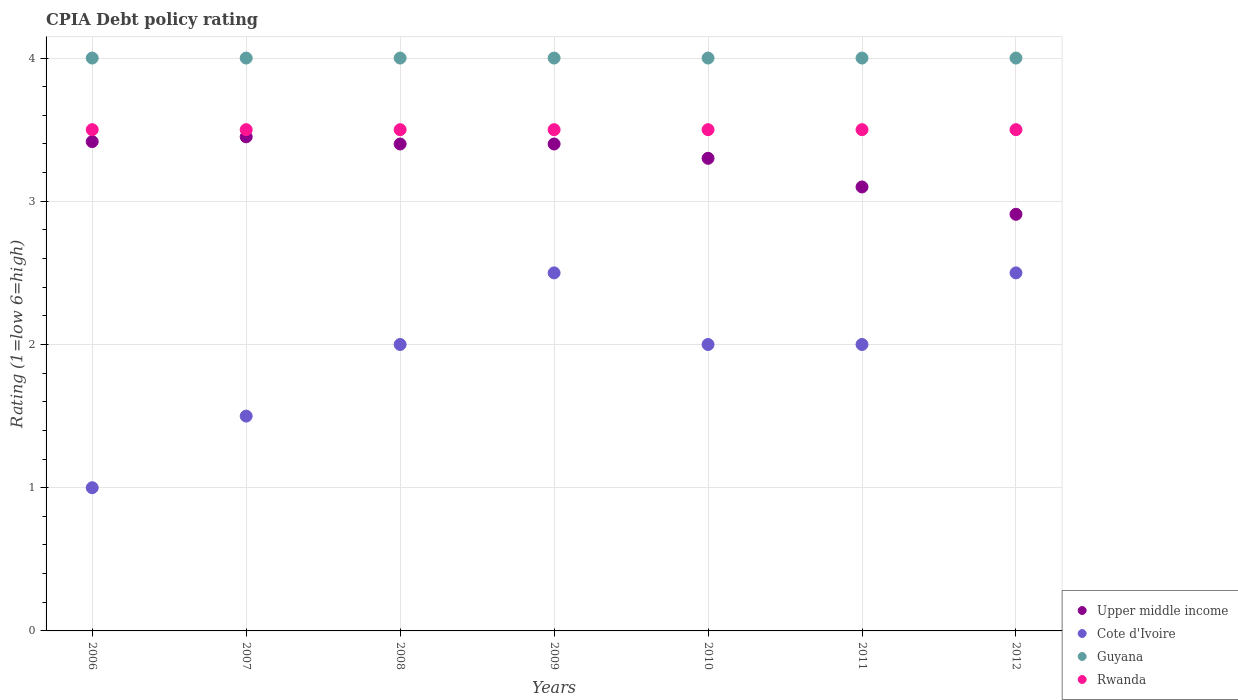What is the CPIA rating in Upper middle income in 2009?
Offer a very short reply. 3.4. In which year was the CPIA rating in Upper middle income maximum?
Ensure brevity in your answer.  2007. In which year was the CPIA rating in Upper middle income minimum?
Your response must be concise. 2012. What is the difference between the CPIA rating in Rwanda in 2006 and the CPIA rating in Cote d'Ivoire in 2008?
Your answer should be very brief. 1.5. What is the average CPIA rating in Guyana per year?
Your answer should be compact. 4. In the year 2012, what is the difference between the CPIA rating in Rwanda and CPIA rating in Upper middle income?
Keep it short and to the point. 0.59. What is the ratio of the CPIA rating in Cote d'Ivoire in 2007 to that in 2011?
Your answer should be compact. 0.75. Is the difference between the CPIA rating in Rwanda in 2008 and 2010 greater than the difference between the CPIA rating in Upper middle income in 2008 and 2010?
Your response must be concise. No. In how many years, is the CPIA rating in Upper middle income greater than the average CPIA rating in Upper middle income taken over all years?
Your answer should be very brief. 5. Is the sum of the CPIA rating in Upper middle income in 2007 and 2010 greater than the maximum CPIA rating in Guyana across all years?
Give a very brief answer. Yes. Is it the case that in every year, the sum of the CPIA rating in Rwanda and CPIA rating in Guyana  is greater than the sum of CPIA rating in Upper middle income and CPIA rating in Cote d'Ivoire?
Provide a short and direct response. Yes. Is it the case that in every year, the sum of the CPIA rating in Cote d'Ivoire and CPIA rating in Rwanda  is greater than the CPIA rating in Upper middle income?
Provide a short and direct response. Yes. Is the CPIA rating in Rwanda strictly greater than the CPIA rating in Guyana over the years?
Keep it short and to the point. No. How many years are there in the graph?
Offer a terse response. 7. Are the values on the major ticks of Y-axis written in scientific E-notation?
Your answer should be compact. No. Does the graph contain any zero values?
Give a very brief answer. No. What is the title of the graph?
Your answer should be compact. CPIA Debt policy rating. What is the label or title of the Y-axis?
Your response must be concise. Rating (1=low 6=high). What is the Rating (1=low 6=high) in Upper middle income in 2006?
Offer a terse response. 3.42. What is the Rating (1=low 6=high) of Cote d'Ivoire in 2006?
Offer a very short reply. 1. What is the Rating (1=low 6=high) in Upper middle income in 2007?
Offer a very short reply. 3.45. What is the Rating (1=low 6=high) in Rwanda in 2007?
Your answer should be compact. 3.5. What is the Rating (1=low 6=high) of Upper middle income in 2008?
Your answer should be compact. 3.4. What is the Rating (1=low 6=high) of Cote d'Ivoire in 2009?
Your answer should be very brief. 2.5. What is the Rating (1=low 6=high) of Guyana in 2010?
Ensure brevity in your answer.  4. What is the Rating (1=low 6=high) of Rwanda in 2010?
Keep it short and to the point. 3.5. What is the Rating (1=low 6=high) in Upper middle income in 2012?
Ensure brevity in your answer.  2.91. What is the Rating (1=low 6=high) in Cote d'Ivoire in 2012?
Your answer should be very brief. 2.5. Across all years, what is the maximum Rating (1=low 6=high) of Upper middle income?
Offer a very short reply. 3.45. Across all years, what is the minimum Rating (1=low 6=high) of Upper middle income?
Offer a very short reply. 2.91. Across all years, what is the minimum Rating (1=low 6=high) in Guyana?
Keep it short and to the point. 4. What is the total Rating (1=low 6=high) in Upper middle income in the graph?
Provide a short and direct response. 22.98. What is the total Rating (1=low 6=high) in Guyana in the graph?
Your response must be concise. 28. What is the difference between the Rating (1=low 6=high) of Upper middle income in 2006 and that in 2007?
Make the answer very short. -0.03. What is the difference between the Rating (1=low 6=high) in Rwanda in 2006 and that in 2007?
Provide a short and direct response. 0. What is the difference between the Rating (1=low 6=high) of Upper middle income in 2006 and that in 2008?
Provide a short and direct response. 0.02. What is the difference between the Rating (1=low 6=high) in Cote d'Ivoire in 2006 and that in 2008?
Keep it short and to the point. -1. What is the difference between the Rating (1=low 6=high) of Upper middle income in 2006 and that in 2009?
Keep it short and to the point. 0.02. What is the difference between the Rating (1=low 6=high) in Cote d'Ivoire in 2006 and that in 2009?
Give a very brief answer. -1.5. What is the difference between the Rating (1=low 6=high) in Guyana in 2006 and that in 2009?
Offer a very short reply. 0. What is the difference between the Rating (1=low 6=high) of Rwanda in 2006 and that in 2009?
Offer a terse response. 0. What is the difference between the Rating (1=low 6=high) in Upper middle income in 2006 and that in 2010?
Provide a short and direct response. 0.12. What is the difference between the Rating (1=low 6=high) in Cote d'Ivoire in 2006 and that in 2010?
Provide a short and direct response. -1. What is the difference between the Rating (1=low 6=high) in Guyana in 2006 and that in 2010?
Keep it short and to the point. 0. What is the difference between the Rating (1=low 6=high) of Rwanda in 2006 and that in 2010?
Your answer should be very brief. 0. What is the difference between the Rating (1=low 6=high) of Upper middle income in 2006 and that in 2011?
Your response must be concise. 0.32. What is the difference between the Rating (1=low 6=high) in Guyana in 2006 and that in 2011?
Provide a succinct answer. 0. What is the difference between the Rating (1=low 6=high) in Rwanda in 2006 and that in 2011?
Offer a terse response. 0. What is the difference between the Rating (1=low 6=high) of Upper middle income in 2006 and that in 2012?
Your answer should be very brief. 0.51. What is the difference between the Rating (1=low 6=high) in Cote d'Ivoire in 2006 and that in 2012?
Your answer should be very brief. -1.5. What is the difference between the Rating (1=low 6=high) of Rwanda in 2006 and that in 2012?
Provide a short and direct response. 0. What is the difference between the Rating (1=low 6=high) in Cote d'Ivoire in 2007 and that in 2008?
Keep it short and to the point. -0.5. What is the difference between the Rating (1=low 6=high) of Upper middle income in 2007 and that in 2009?
Offer a very short reply. 0.05. What is the difference between the Rating (1=low 6=high) of Cote d'Ivoire in 2007 and that in 2009?
Your answer should be compact. -1. What is the difference between the Rating (1=low 6=high) of Rwanda in 2007 and that in 2009?
Provide a succinct answer. 0. What is the difference between the Rating (1=low 6=high) in Upper middle income in 2007 and that in 2010?
Your answer should be very brief. 0.15. What is the difference between the Rating (1=low 6=high) of Rwanda in 2007 and that in 2010?
Your answer should be compact. 0. What is the difference between the Rating (1=low 6=high) in Upper middle income in 2007 and that in 2011?
Provide a short and direct response. 0.35. What is the difference between the Rating (1=low 6=high) of Cote d'Ivoire in 2007 and that in 2011?
Ensure brevity in your answer.  -0.5. What is the difference between the Rating (1=low 6=high) of Upper middle income in 2007 and that in 2012?
Provide a short and direct response. 0.54. What is the difference between the Rating (1=low 6=high) in Guyana in 2007 and that in 2012?
Make the answer very short. 0. What is the difference between the Rating (1=low 6=high) in Upper middle income in 2008 and that in 2009?
Make the answer very short. 0. What is the difference between the Rating (1=low 6=high) of Cote d'Ivoire in 2008 and that in 2010?
Your response must be concise. 0. What is the difference between the Rating (1=low 6=high) of Guyana in 2008 and that in 2010?
Give a very brief answer. 0. What is the difference between the Rating (1=low 6=high) in Upper middle income in 2008 and that in 2011?
Make the answer very short. 0.3. What is the difference between the Rating (1=low 6=high) of Guyana in 2008 and that in 2011?
Your answer should be compact. 0. What is the difference between the Rating (1=low 6=high) of Upper middle income in 2008 and that in 2012?
Your answer should be compact. 0.49. What is the difference between the Rating (1=low 6=high) in Guyana in 2008 and that in 2012?
Provide a short and direct response. 0. What is the difference between the Rating (1=low 6=high) of Upper middle income in 2009 and that in 2010?
Provide a short and direct response. 0.1. What is the difference between the Rating (1=low 6=high) in Rwanda in 2009 and that in 2010?
Give a very brief answer. 0. What is the difference between the Rating (1=low 6=high) in Cote d'Ivoire in 2009 and that in 2011?
Provide a succinct answer. 0.5. What is the difference between the Rating (1=low 6=high) of Guyana in 2009 and that in 2011?
Provide a short and direct response. 0. What is the difference between the Rating (1=low 6=high) in Upper middle income in 2009 and that in 2012?
Ensure brevity in your answer.  0.49. What is the difference between the Rating (1=low 6=high) of Cote d'Ivoire in 2009 and that in 2012?
Make the answer very short. 0. What is the difference between the Rating (1=low 6=high) in Rwanda in 2009 and that in 2012?
Offer a terse response. 0. What is the difference between the Rating (1=low 6=high) of Upper middle income in 2010 and that in 2011?
Provide a short and direct response. 0.2. What is the difference between the Rating (1=low 6=high) in Cote d'Ivoire in 2010 and that in 2011?
Your answer should be very brief. 0. What is the difference between the Rating (1=low 6=high) of Guyana in 2010 and that in 2011?
Your answer should be compact. 0. What is the difference between the Rating (1=low 6=high) in Rwanda in 2010 and that in 2011?
Provide a short and direct response. 0. What is the difference between the Rating (1=low 6=high) of Upper middle income in 2010 and that in 2012?
Your answer should be very brief. 0.39. What is the difference between the Rating (1=low 6=high) in Guyana in 2010 and that in 2012?
Your response must be concise. 0. What is the difference between the Rating (1=low 6=high) of Upper middle income in 2011 and that in 2012?
Ensure brevity in your answer.  0.19. What is the difference between the Rating (1=low 6=high) in Upper middle income in 2006 and the Rating (1=low 6=high) in Cote d'Ivoire in 2007?
Provide a short and direct response. 1.92. What is the difference between the Rating (1=low 6=high) in Upper middle income in 2006 and the Rating (1=low 6=high) in Guyana in 2007?
Provide a short and direct response. -0.58. What is the difference between the Rating (1=low 6=high) of Upper middle income in 2006 and the Rating (1=low 6=high) of Rwanda in 2007?
Provide a short and direct response. -0.08. What is the difference between the Rating (1=low 6=high) in Cote d'Ivoire in 2006 and the Rating (1=low 6=high) in Guyana in 2007?
Your response must be concise. -3. What is the difference between the Rating (1=low 6=high) in Cote d'Ivoire in 2006 and the Rating (1=low 6=high) in Rwanda in 2007?
Provide a short and direct response. -2.5. What is the difference between the Rating (1=low 6=high) of Guyana in 2006 and the Rating (1=low 6=high) of Rwanda in 2007?
Your response must be concise. 0.5. What is the difference between the Rating (1=low 6=high) in Upper middle income in 2006 and the Rating (1=low 6=high) in Cote d'Ivoire in 2008?
Give a very brief answer. 1.42. What is the difference between the Rating (1=low 6=high) of Upper middle income in 2006 and the Rating (1=low 6=high) of Guyana in 2008?
Ensure brevity in your answer.  -0.58. What is the difference between the Rating (1=low 6=high) in Upper middle income in 2006 and the Rating (1=low 6=high) in Rwanda in 2008?
Your answer should be compact. -0.08. What is the difference between the Rating (1=low 6=high) in Cote d'Ivoire in 2006 and the Rating (1=low 6=high) in Guyana in 2008?
Give a very brief answer. -3. What is the difference between the Rating (1=low 6=high) of Cote d'Ivoire in 2006 and the Rating (1=low 6=high) of Rwanda in 2008?
Offer a very short reply. -2.5. What is the difference between the Rating (1=low 6=high) of Upper middle income in 2006 and the Rating (1=low 6=high) of Guyana in 2009?
Your answer should be compact. -0.58. What is the difference between the Rating (1=low 6=high) in Upper middle income in 2006 and the Rating (1=low 6=high) in Rwanda in 2009?
Offer a very short reply. -0.08. What is the difference between the Rating (1=low 6=high) in Cote d'Ivoire in 2006 and the Rating (1=low 6=high) in Guyana in 2009?
Your answer should be compact. -3. What is the difference between the Rating (1=low 6=high) in Guyana in 2006 and the Rating (1=low 6=high) in Rwanda in 2009?
Offer a very short reply. 0.5. What is the difference between the Rating (1=low 6=high) of Upper middle income in 2006 and the Rating (1=low 6=high) of Cote d'Ivoire in 2010?
Give a very brief answer. 1.42. What is the difference between the Rating (1=low 6=high) in Upper middle income in 2006 and the Rating (1=low 6=high) in Guyana in 2010?
Provide a short and direct response. -0.58. What is the difference between the Rating (1=low 6=high) in Upper middle income in 2006 and the Rating (1=low 6=high) in Rwanda in 2010?
Give a very brief answer. -0.08. What is the difference between the Rating (1=low 6=high) in Cote d'Ivoire in 2006 and the Rating (1=low 6=high) in Guyana in 2010?
Provide a short and direct response. -3. What is the difference between the Rating (1=low 6=high) of Upper middle income in 2006 and the Rating (1=low 6=high) of Cote d'Ivoire in 2011?
Your answer should be very brief. 1.42. What is the difference between the Rating (1=low 6=high) of Upper middle income in 2006 and the Rating (1=low 6=high) of Guyana in 2011?
Your answer should be very brief. -0.58. What is the difference between the Rating (1=low 6=high) of Upper middle income in 2006 and the Rating (1=low 6=high) of Rwanda in 2011?
Provide a succinct answer. -0.08. What is the difference between the Rating (1=low 6=high) of Cote d'Ivoire in 2006 and the Rating (1=low 6=high) of Guyana in 2011?
Give a very brief answer. -3. What is the difference between the Rating (1=low 6=high) of Upper middle income in 2006 and the Rating (1=low 6=high) of Cote d'Ivoire in 2012?
Give a very brief answer. 0.92. What is the difference between the Rating (1=low 6=high) in Upper middle income in 2006 and the Rating (1=low 6=high) in Guyana in 2012?
Your answer should be very brief. -0.58. What is the difference between the Rating (1=low 6=high) in Upper middle income in 2006 and the Rating (1=low 6=high) in Rwanda in 2012?
Your response must be concise. -0.08. What is the difference between the Rating (1=low 6=high) in Cote d'Ivoire in 2006 and the Rating (1=low 6=high) in Guyana in 2012?
Your answer should be very brief. -3. What is the difference between the Rating (1=low 6=high) in Guyana in 2006 and the Rating (1=low 6=high) in Rwanda in 2012?
Your answer should be compact. 0.5. What is the difference between the Rating (1=low 6=high) in Upper middle income in 2007 and the Rating (1=low 6=high) in Cote d'Ivoire in 2008?
Your answer should be very brief. 1.45. What is the difference between the Rating (1=low 6=high) in Upper middle income in 2007 and the Rating (1=low 6=high) in Guyana in 2008?
Offer a very short reply. -0.55. What is the difference between the Rating (1=low 6=high) of Guyana in 2007 and the Rating (1=low 6=high) of Rwanda in 2008?
Provide a succinct answer. 0.5. What is the difference between the Rating (1=low 6=high) of Upper middle income in 2007 and the Rating (1=low 6=high) of Guyana in 2009?
Your response must be concise. -0.55. What is the difference between the Rating (1=low 6=high) of Upper middle income in 2007 and the Rating (1=low 6=high) of Rwanda in 2009?
Ensure brevity in your answer.  -0.05. What is the difference between the Rating (1=low 6=high) in Cote d'Ivoire in 2007 and the Rating (1=low 6=high) in Guyana in 2009?
Provide a short and direct response. -2.5. What is the difference between the Rating (1=low 6=high) of Cote d'Ivoire in 2007 and the Rating (1=low 6=high) of Rwanda in 2009?
Your answer should be very brief. -2. What is the difference between the Rating (1=low 6=high) in Guyana in 2007 and the Rating (1=low 6=high) in Rwanda in 2009?
Keep it short and to the point. 0.5. What is the difference between the Rating (1=low 6=high) in Upper middle income in 2007 and the Rating (1=low 6=high) in Cote d'Ivoire in 2010?
Your answer should be compact. 1.45. What is the difference between the Rating (1=low 6=high) in Upper middle income in 2007 and the Rating (1=low 6=high) in Guyana in 2010?
Your answer should be very brief. -0.55. What is the difference between the Rating (1=low 6=high) in Cote d'Ivoire in 2007 and the Rating (1=low 6=high) in Rwanda in 2010?
Offer a very short reply. -2. What is the difference between the Rating (1=low 6=high) in Guyana in 2007 and the Rating (1=low 6=high) in Rwanda in 2010?
Keep it short and to the point. 0.5. What is the difference between the Rating (1=low 6=high) in Upper middle income in 2007 and the Rating (1=low 6=high) in Cote d'Ivoire in 2011?
Give a very brief answer. 1.45. What is the difference between the Rating (1=low 6=high) of Upper middle income in 2007 and the Rating (1=low 6=high) of Guyana in 2011?
Provide a succinct answer. -0.55. What is the difference between the Rating (1=low 6=high) of Cote d'Ivoire in 2007 and the Rating (1=low 6=high) of Guyana in 2011?
Keep it short and to the point. -2.5. What is the difference between the Rating (1=low 6=high) in Cote d'Ivoire in 2007 and the Rating (1=low 6=high) in Rwanda in 2011?
Your response must be concise. -2. What is the difference between the Rating (1=low 6=high) of Upper middle income in 2007 and the Rating (1=low 6=high) of Cote d'Ivoire in 2012?
Your answer should be compact. 0.95. What is the difference between the Rating (1=low 6=high) in Upper middle income in 2007 and the Rating (1=low 6=high) in Guyana in 2012?
Offer a very short reply. -0.55. What is the difference between the Rating (1=low 6=high) in Upper middle income in 2007 and the Rating (1=low 6=high) in Rwanda in 2012?
Ensure brevity in your answer.  -0.05. What is the difference between the Rating (1=low 6=high) of Cote d'Ivoire in 2007 and the Rating (1=low 6=high) of Guyana in 2012?
Provide a succinct answer. -2.5. What is the difference between the Rating (1=low 6=high) of Guyana in 2007 and the Rating (1=low 6=high) of Rwanda in 2012?
Your answer should be very brief. 0.5. What is the difference between the Rating (1=low 6=high) in Upper middle income in 2008 and the Rating (1=low 6=high) in Cote d'Ivoire in 2009?
Ensure brevity in your answer.  0.9. What is the difference between the Rating (1=low 6=high) in Cote d'Ivoire in 2008 and the Rating (1=low 6=high) in Rwanda in 2009?
Your answer should be very brief. -1.5. What is the difference between the Rating (1=low 6=high) in Upper middle income in 2008 and the Rating (1=low 6=high) in Cote d'Ivoire in 2010?
Offer a terse response. 1.4. What is the difference between the Rating (1=low 6=high) in Upper middle income in 2008 and the Rating (1=low 6=high) in Guyana in 2010?
Your answer should be compact. -0.6. What is the difference between the Rating (1=low 6=high) of Cote d'Ivoire in 2008 and the Rating (1=low 6=high) of Guyana in 2010?
Your response must be concise. -2. What is the difference between the Rating (1=low 6=high) in Cote d'Ivoire in 2008 and the Rating (1=low 6=high) in Rwanda in 2010?
Provide a succinct answer. -1.5. What is the difference between the Rating (1=low 6=high) in Guyana in 2008 and the Rating (1=low 6=high) in Rwanda in 2010?
Provide a succinct answer. 0.5. What is the difference between the Rating (1=low 6=high) of Upper middle income in 2008 and the Rating (1=low 6=high) of Cote d'Ivoire in 2011?
Provide a short and direct response. 1.4. What is the difference between the Rating (1=low 6=high) in Cote d'Ivoire in 2008 and the Rating (1=low 6=high) in Guyana in 2011?
Make the answer very short. -2. What is the difference between the Rating (1=low 6=high) of Cote d'Ivoire in 2008 and the Rating (1=low 6=high) of Rwanda in 2011?
Offer a very short reply. -1.5. What is the difference between the Rating (1=low 6=high) in Guyana in 2008 and the Rating (1=low 6=high) in Rwanda in 2011?
Your response must be concise. 0.5. What is the difference between the Rating (1=low 6=high) in Upper middle income in 2008 and the Rating (1=low 6=high) in Cote d'Ivoire in 2012?
Your response must be concise. 0.9. What is the difference between the Rating (1=low 6=high) in Guyana in 2008 and the Rating (1=low 6=high) in Rwanda in 2012?
Keep it short and to the point. 0.5. What is the difference between the Rating (1=low 6=high) of Upper middle income in 2009 and the Rating (1=low 6=high) of Guyana in 2010?
Your answer should be very brief. -0.6. What is the difference between the Rating (1=low 6=high) of Cote d'Ivoire in 2009 and the Rating (1=low 6=high) of Guyana in 2010?
Keep it short and to the point. -1.5. What is the difference between the Rating (1=low 6=high) in Guyana in 2009 and the Rating (1=low 6=high) in Rwanda in 2010?
Your answer should be compact. 0.5. What is the difference between the Rating (1=low 6=high) in Upper middle income in 2009 and the Rating (1=low 6=high) in Cote d'Ivoire in 2011?
Make the answer very short. 1.4. What is the difference between the Rating (1=low 6=high) in Upper middle income in 2009 and the Rating (1=low 6=high) in Guyana in 2011?
Make the answer very short. -0.6. What is the difference between the Rating (1=low 6=high) in Upper middle income in 2009 and the Rating (1=low 6=high) in Rwanda in 2011?
Provide a short and direct response. -0.1. What is the difference between the Rating (1=low 6=high) of Cote d'Ivoire in 2009 and the Rating (1=low 6=high) of Guyana in 2011?
Give a very brief answer. -1.5. What is the difference between the Rating (1=low 6=high) in Cote d'Ivoire in 2009 and the Rating (1=low 6=high) in Rwanda in 2011?
Your response must be concise. -1. What is the difference between the Rating (1=low 6=high) in Upper middle income in 2009 and the Rating (1=low 6=high) in Guyana in 2012?
Provide a short and direct response. -0.6. What is the difference between the Rating (1=low 6=high) in Cote d'Ivoire in 2009 and the Rating (1=low 6=high) in Guyana in 2012?
Give a very brief answer. -1.5. What is the difference between the Rating (1=low 6=high) of Cote d'Ivoire in 2009 and the Rating (1=low 6=high) of Rwanda in 2012?
Your answer should be compact. -1. What is the difference between the Rating (1=low 6=high) of Guyana in 2009 and the Rating (1=low 6=high) of Rwanda in 2012?
Offer a terse response. 0.5. What is the difference between the Rating (1=low 6=high) in Upper middle income in 2010 and the Rating (1=low 6=high) in Cote d'Ivoire in 2011?
Make the answer very short. 1.3. What is the difference between the Rating (1=low 6=high) of Upper middle income in 2010 and the Rating (1=low 6=high) of Rwanda in 2011?
Offer a very short reply. -0.2. What is the difference between the Rating (1=low 6=high) of Guyana in 2010 and the Rating (1=low 6=high) of Rwanda in 2011?
Provide a short and direct response. 0.5. What is the difference between the Rating (1=low 6=high) of Upper middle income in 2010 and the Rating (1=low 6=high) of Cote d'Ivoire in 2012?
Provide a succinct answer. 0.8. What is the difference between the Rating (1=low 6=high) in Upper middle income in 2010 and the Rating (1=low 6=high) in Guyana in 2012?
Give a very brief answer. -0.7. What is the difference between the Rating (1=low 6=high) of Upper middle income in 2010 and the Rating (1=low 6=high) of Rwanda in 2012?
Give a very brief answer. -0.2. What is the difference between the Rating (1=low 6=high) in Cote d'Ivoire in 2010 and the Rating (1=low 6=high) in Guyana in 2012?
Provide a succinct answer. -2. What is the difference between the Rating (1=low 6=high) in Upper middle income in 2011 and the Rating (1=low 6=high) in Rwanda in 2012?
Ensure brevity in your answer.  -0.4. What is the difference between the Rating (1=low 6=high) in Cote d'Ivoire in 2011 and the Rating (1=low 6=high) in Guyana in 2012?
Provide a short and direct response. -2. What is the difference between the Rating (1=low 6=high) of Cote d'Ivoire in 2011 and the Rating (1=low 6=high) of Rwanda in 2012?
Keep it short and to the point. -1.5. What is the difference between the Rating (1=low 6=high) in Guyana in 2011 and the Rating (1=low 6=high) in Rwanda in 2012?
Provide a short and direct response. 0.5. What is the average Rating (1=low 6=high) in Upper middle income per year?
Provide a succinct answer. 3.28. What is the average Rating (1=low 6=high) of Cote d'Ivoire per year?
Make the answer very short. 1.93. What is the average Rating (1=low 6=high) in Rwanda per year?
Your response must be concise. 3.5. In the year 2006, what is the difference between the Rating (1=low 6=high) in Upper middle income and Rating (1=low 6=high) in Cote d'Ivoire?
Offer a terse response. 2.42. In the year 2006, what is the difference between the Rating (1=low 6=high) of Upper middle income and Rating (1=low 6=high) of Guyana?
Your answer should be compact. -0.58. In the year 2006, what is the difference between the Rating (1=low 6=high) of Upper middle income and Rating (1=low 6=high) of Rwanda?
Offer a very short reply. -0.08. In the year 2006, what is the difference between the Rating (1=low 6=high) in Cote d'Ivoire and Rating (1=low 6=high) in Guyana?
Your answer should be compact. -3. In the year 2006, what is the difference between the Rating (1=low 6=high) of Cote d'Ivoire and Rating (1=low 6=high) of Rwanda?
Your answer should be very brief. -2.5. In the year 2006, what is the difference between the Rating (1=low 6=high) of Guyana and Rating (1=low 6=high) of Rwanda?
Provide a short and direct response. 0.5. In the year 2007, what is the difference between the Rating (1=low 6=high) in Upper middle income and Rating (1=low 6=high) in Cote d'Ivoire?
Your answer should be very brief. 1.95. In the year 2007, what is the difference between the Rating (1=low 6=high) in Upper middle income and Rating (1=low 6=high) in Guyana?
Ensure brevity in your answer.  -0.55. In the year 2007, what is the difference between the Rating (1=low 6=high) in Upper middle income and Rating (1=low 6=high) in Rwanda?
Keep it short and to the point. -0.05. In the year 2007, what is the difference between the Rating (1=low 6=high) of Cote d'Ivoire and Rating (1=low 6=high) of Rwanda?
Your answer should be compact. -2. In the year 2008, what is the difference between the Rating (1=low 6=high) in Upper middle income and Rating (1=low 6=high) in Cote d'Ivoire?
Give a very brief answer. 1.4. In the year 2008, what is the difference between the Rating (1=low 6=high) of Cote d'Ivoire and Rating (1=low 6=high) of Guyana?
Ensure brevity in your answer.  -2. In the year 2009, what is the difference between the Rating (1=low 6=high) in Upper middle income and Rating (1=low 6=high) in Guyana?
Ensure brevity in your answer.  -0.6. In the year 2010, what is the difference between the Rating (1=low 6=high) of Upper middle income and Rating (1=low 6=high) of Cote d'Ivoire?
Provide a succinct answer. 1.3. In the year 2010, what is the difference between the Rating (1=low 6=high) in Upper middle income and Rating (1=low 6=high) in Guyana?
Your answer should be compact. -0.7. In the year 2010, what is the difference between the Rating (1=low 6=high) of Guyana and Rating (1=low 6=high) of Rwanda?
Offer a very short reply. 0.5. In the year 2011, what is the difference between the Rating (1=low 6=high) in Upper middle income and Rating (1=low 6=high) in Rwanda?
Make the answer very short. -0.4. In the year 2011, what is the difference between the Rating (1=low 6=high) in Cote d'Ivoire and Rating (1=low 6=high) in Guyana?
Your answer should be very brief. -2. In the year 2011, what is the difference between the Rating (1=low 6=high) in Cote d'Ivoire and Rating (1=low 6=high) in Rwanda?
Provide a succinct answer. -1.5. In the year 2012, what is the difference between the Rating (1=low 6=high) in Upper middle income and Rating (1=low 6=high) in Cote d'Ivoire?
Provide a short and direct response. 0.41. In the year 2012, what is the difference between the Rating (1=low 6=high) in Upper middle income and Rating (1=low 6=high) in Guyana?
Make the answer very short. -1.09. In the year 2012, what is the difference between the Rating (1=low 6=high) of Upper middle income and Rating (1=low 6=high) of Rwanda?
Your answer should be very brief. -0.59. In the year 2012, what is the difference between the Rating (1=low 6=high) in Cote d'Ivoire and Rating (1=low 6=high) in Guyana?
Your answer should be very brief. -1.5. In the year 2012, what is the difference between the Rating (1=low 6=high) of Guyana and Rating (1=low 6=high) of Rwanda?
Make the answer very short. 0.5. What is the ratio of the Rating (1=low 6=high) of Upper middle income in 2006 to that in 2007?
Your answer should be compact. 0.99. What is the ratio of the Rating (1=low 6=high) in Guyana in 2006 to that in 2007?
Offer a very short reply. 1. What is the ratio of the Rating (1=low 6=high) in Upper middle income in 2006 to that in 2008?
Ensure brevity in your answer.  1. What is the ratio of the Rating (1=low 6=high) of Cote d'Ivoire in 2006 to that in 2008?
Provide a succinct answer. 0.5. What is the ratio of the Rating (1=low 6=high) of Guyana in 2006 to that in 2008?
Keep it short and to the point. 1. What is the ratio of the Rating (1=low 6=high) in Rwanda in 2006 to that in 2008?
Your answer should be very brief. 1. What is the ratio of the Rating (1=low 6=high) of Rwanda in 2006 to that in 2009?
Your answer should be compact. 1. What is the ratio of the Rating (1=low 6=high) of Upper middle income in 2006 to that in 2010?
Provide a succinct answer. 1.04. What is the ratio of the Rating (1=low 6=high) in Guyana in 2006 to that in 2010?
Provide a succinct answer. 1. What is the ratio of the Rating (1=low 6=high) of Upper middle income in 2006 to that in 2011?
Your response must be concise. 1.1. What is the ratio of the Rating (1=low 6=high) in Cote d'Ivoire in 2006 to that in 2011?
Make the answer very short. 0.5. What is the ratio of the Rating (1=low 6=high) of Guyana in 2006 to that in 2011?
Give a very brief answer. 1. What is the ratio of the Rating (1=low 6=high) in Upper middle income in 2006 to that in 2012?
Provide a short and direct response. 1.17. What is the ratio of the Rating (1=low 6=high) of Cote d'Ivoire in 2006 to that in 2012?
Your answer should be compact. 0.4. What is the ratio of the Rating (1=low 6=high) in Upper middle income in 2007 to that in 2008?
Provide a short and direct response. 1.01. What is the ratio of the Rating (1=low 6=high) of Guyana in 2007 to that in 2008?
Your response must be concise. 1. What is the ratio of the Rating (1=low 6=high) in Upper middle income in 2007 to that in 2009?
Offer a very short reply. 1.01. What is the ratio of the Rating (1=low 6=high) of Upper middle income in 2007 to that in 2010?
Your response must be concise. 1.05. What is the ratio of the Rating (1=low 6=high) in Upper middle income in 2007 to that in 2011?
Give a very brief answer. 1.11. What is the ratio of the Rating (1=low 6=high) of Rwanda in 2007 to that in 2011?
Ensure brevity in your answer.  1. What is the ratio of the Rating (1=low 6=high) in Upper middle income in 2007 to that in 2012?
Your response must be concise. 1.19. What is the ratio of the Rating (1=low 6=high) in Rwanda in 2007 to that in 2012?
Offer a very short reply. 1. What is the ratio of the Rating (1=low 6=high) of Cote d'Ivoire in 2008 to that in 2009?
Your response must be concise. 0.8. What is the ratio of the Rating (1=low 6=high) of Upper middle income in 2008 to that in 2010?
Offer a very short reply. 1.03. What is the ratio of the Rating (1=low 6=high) in Cote d'Ivoire in 2008 to that in 2010?
Provide a short and direct response. 1. What is the ratio of the Rating (1=low 6=high) of Guyana in 2008 to that in 2010?
Your answer should be compact. 1. What is the ratio of the Rating (1=low 6=high) in Upper middle income in 2008 to that in 2011?
Offer a terse response. 1.1. What is the ratio of the Rating (1=low 6=high) of Cote d'Ivoire in 2008 to that in 2011?
Your answer should be very brief. 1. What is the ratio of the Rating (1=low 6=high) in Guyana in 2008 to that in 2011?
Ensure brevity in your answer.  1. What is the ratio of the Rating (1=low 6=high) in Upper middle income in 2008 to that in 2012?
Provide a short and direct response. 1.17. What is the ratio of the Rating (1=low 6=high) of Rwanda in 2008 to that in 2012?
Offer a terse response. 1. What is the ratio of the Rating (1=low 6=high) in Upper middle income in 2009 to that in 2010?
Your response must be concise. 1.03. What is the ratio of the Rating (1=low 6=high) in Cote d'Ivoire in 2009 to that in 2010?
Provide a succinct answer. 1.25. What is the ratio of the Rating (1=low 6=high) in Guyana in 2009 to that in 2010?
Keep it short and to the point. 1. What is the ratio of the Rating (1=low 6=high) in Upper middle income in 2009 to that in 2011?
Your response must be concise. 1.1. What is the ratio of the Rating (1=low 6=high) of Cote d'Ivoire in 2009 to that in 2011?
Keep it short and to the point. 1.25. What is the ratio of the Rating (1=low 6=high) of Rwanda in 2009 to that in 2011?
Ensure brevity in your answer.  1. What is the ratio of the Rating (1=low 6=high) in Upper middle income in 2009 to that in 2012?
Keep it short and to the point. 1.17. What is the ratio of the Rating (1=low 6=high) in Cote d'Ivoire in 2009 to that in 2012?
Give a very brief answer. 1. What is the ratio of the Rating (1=low 6=high) of Rwanda in 2009 to that in 2012?
Your answer should be compact. 1. What is the ratio of the Rating (1=low 6=high) of Upper middle income in 2010 to that in 2011?
Offer a terse response. 1.06. What is the ratio of the Rating (1=low 6=high) in Rwanda in 2010 to that in 2011?
Provide a short and direct response. 1. What is the ratio of the Rating (1=low 6=high) of Upper middle income in 2010 to that in 2012?
Provide a short and direct response. 1.13. What is the ratio of the Rating (1=low 6=high) in Cote d'Ivoire in 2010 to that in 2012?
Your answer should be compact. 0.8. What is the ratio of the Rating (1=low 6=high) of Guyana in 2010 to that in 2012?
Your answer should be very brief. 1. What is the ratio of the Rating (1=low 6=high) in Upper middle income in 2011 to that in 2012?
Give a very brief answer. 1.07. What is the ratio of the Rating (1=low 6=high) in Guyana in 2011 to that in 2012?
Keep it short and to the point. 1. What is the ratio of the Rating (1=low 6=high) of Rwanda in 2011 to that in 2012?
Ensure brevity in your answer.  1. What is the difference between the highest and the second highest Rating (1=low 6=high) of Upper middle income?
Your answer should be compact. 0.03. What is the difference between the highest and the second highest Rating (1=low 6=high) of Cote d'Ivoire?
Offer a very short reply. 0. What is the difference between the highest and the lowest Rating (1=low 6=high) of Upper middle income?
Ensure brevity in your answer.  0.54. What is the difference between the highest and the lowest Rating (1=low 6=high) in Guyana?
Make the answer very short. 0. 